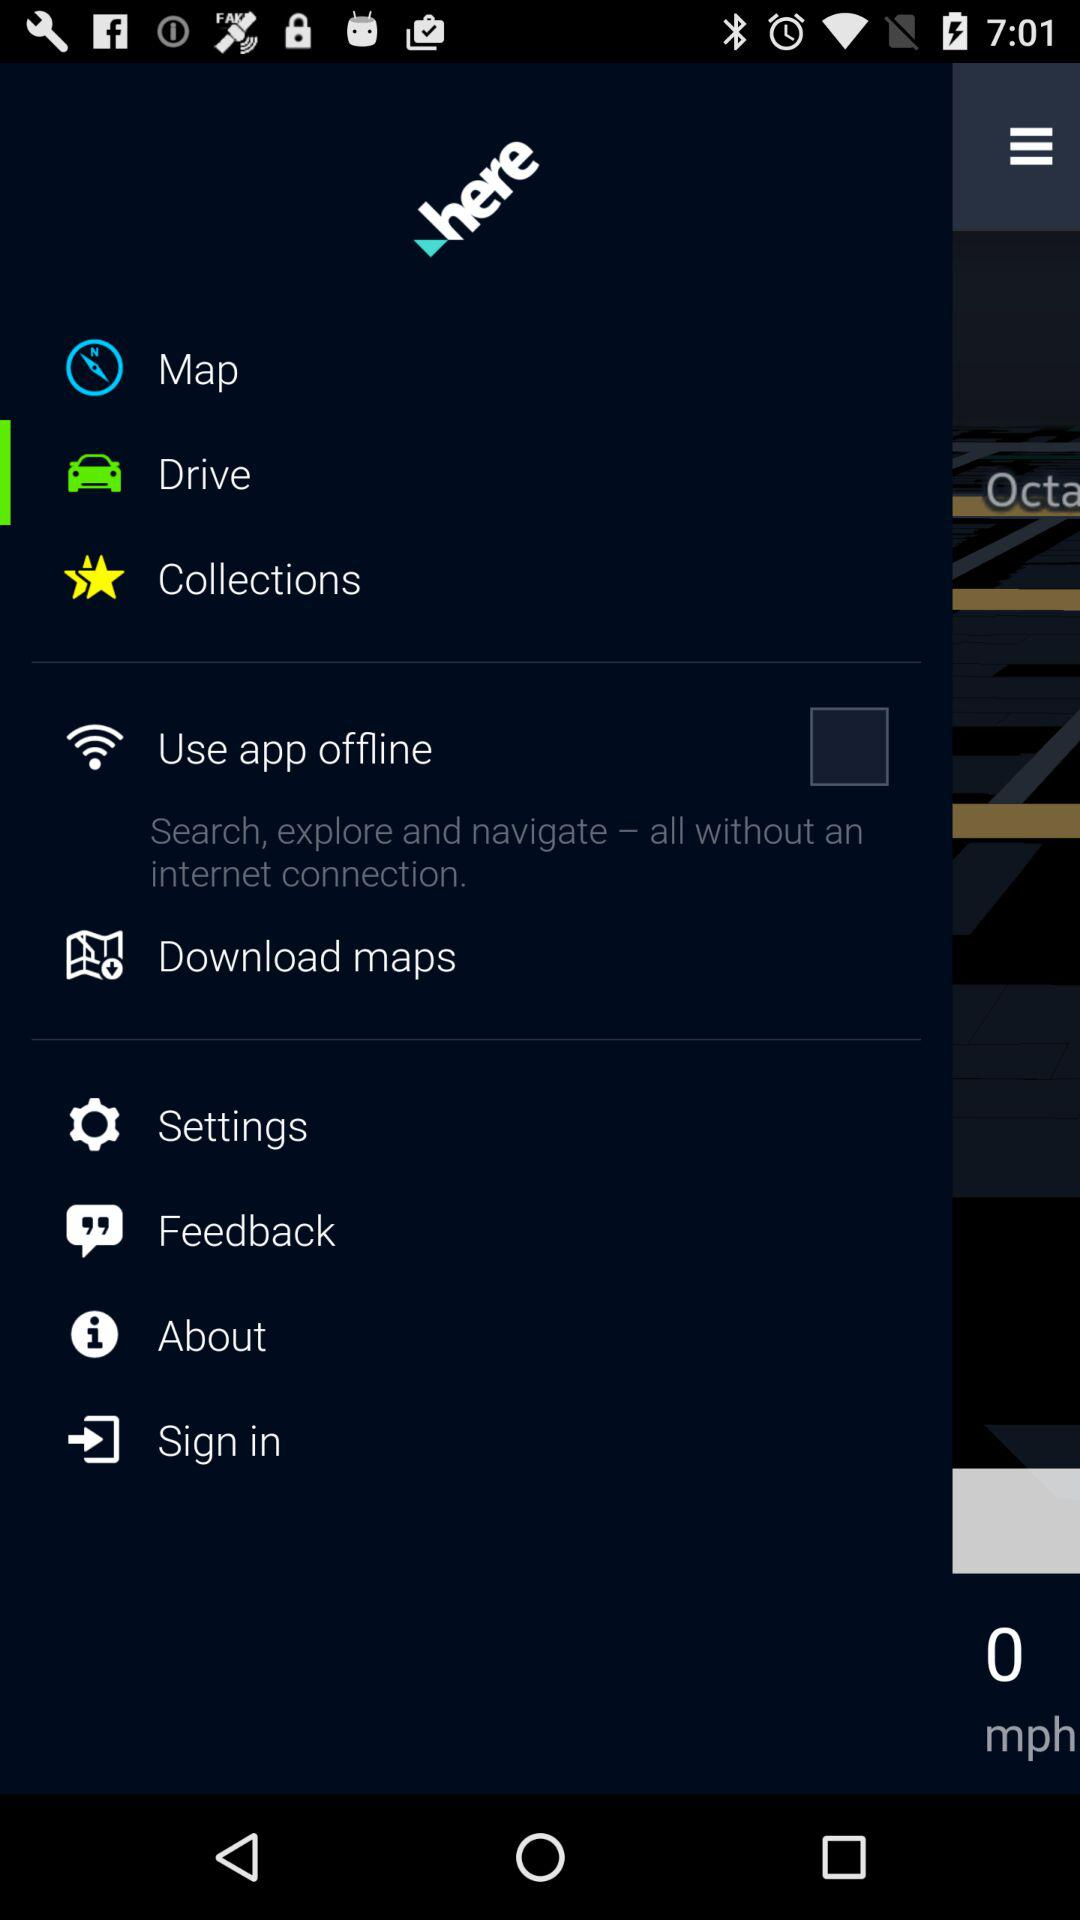What is the status of the "Use app offline"? The status is off. 